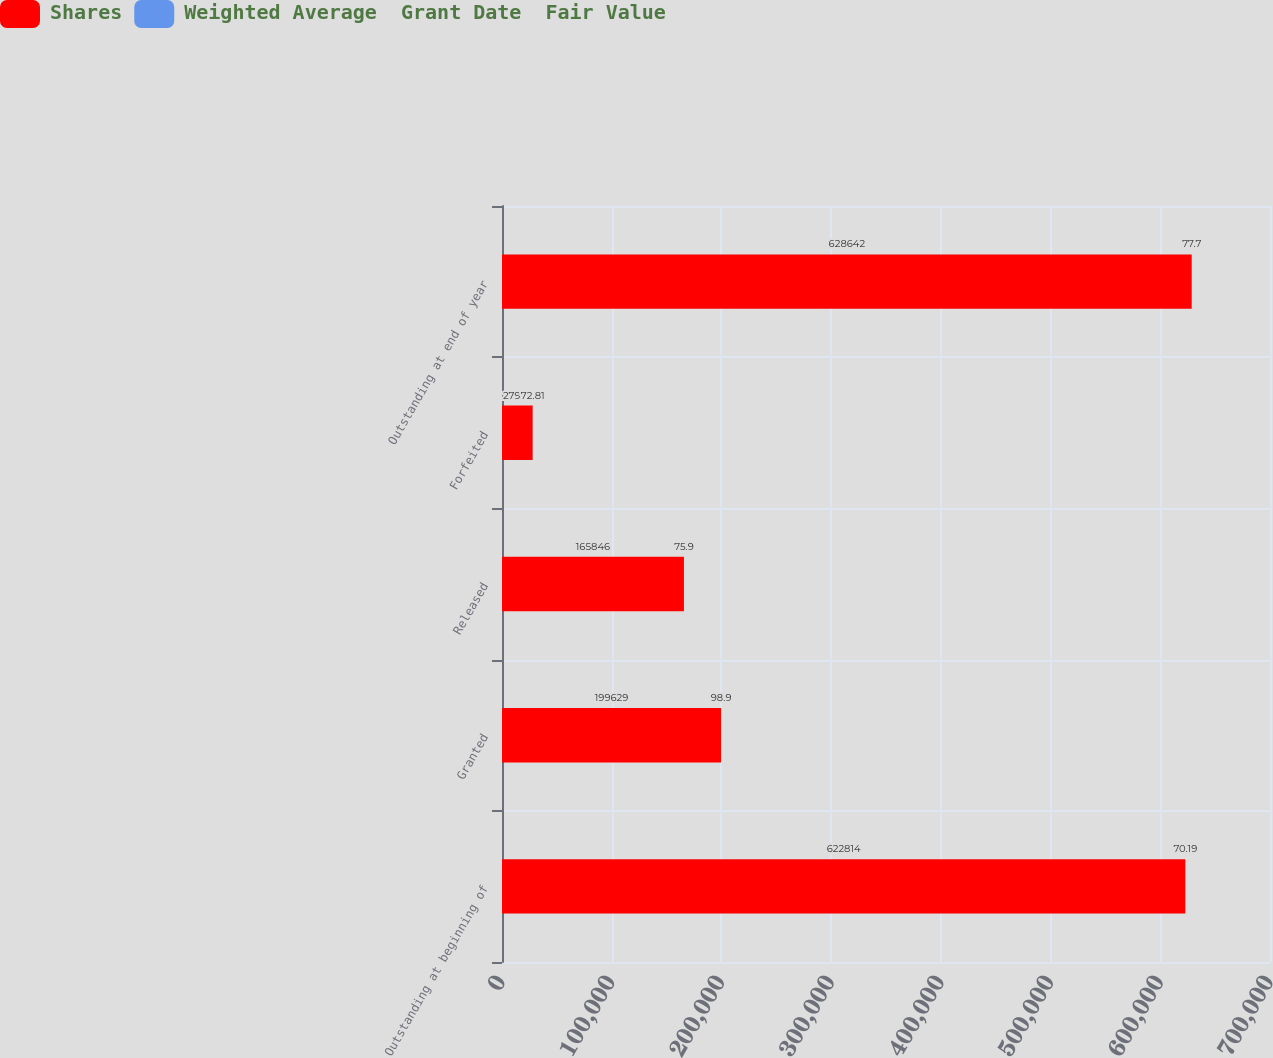Convert chart. <chart><loc_0><loc_0><loc_500><loc_500><stacked_bar_chart><ecel><fcel>Outstanding at beginning of<fcel>Granted<fcel>Released<fcel>Forfeited<fcel>Outstanding at end of year<nl><fcel>Shares<fcel>622814<fcel>199629<fcel>165846<fcel>27955<fcel>628642<nl><fcel>Weighted Average  Grant Date  Fair Value<fcel>70.19<fcel>98.9<fcel>75.9<fcel>72.81<fcel>77.7<nl></chart> 